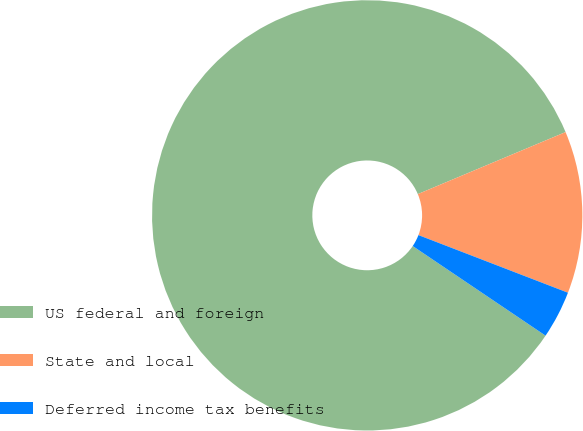<chart> <loc_0><loc_0><loc_500><loc_500><pie_chart><fcel>US federal and foreign<fcel>State and local<fcel>Deferred income tax benefits<nl><fcel>84.23%<fcel>12.18%<fcel>3.59%<nl></chart> 